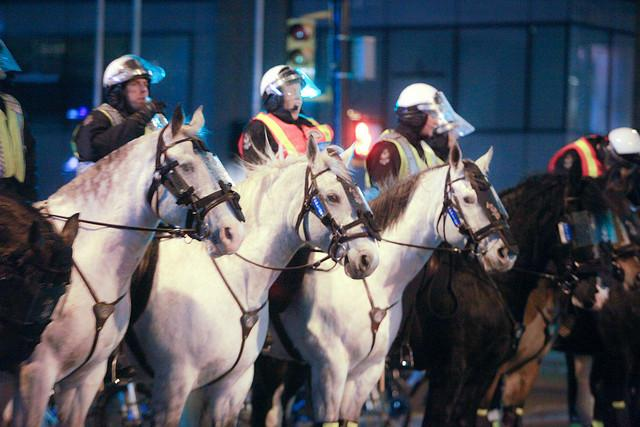What body part is protected by the attachment on the helmets they are wearing? Please explain your reasoning. face. The head of the police are protected by shields. 